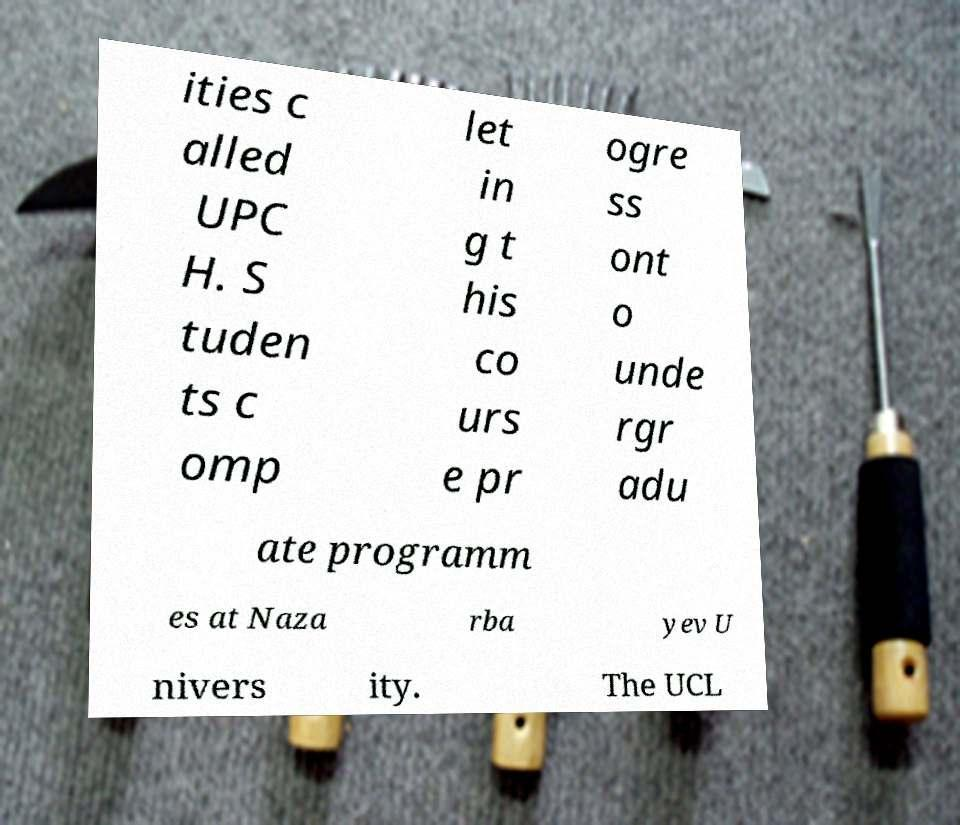Please read and relay the text visible in this image. What does it say? ities c alled UPC H. S tuden ts c omp let in g t his co urs e pr ogre ss ont o unde rgr adu ate programm es at Naza rba yev U nivers ity. The UCL 